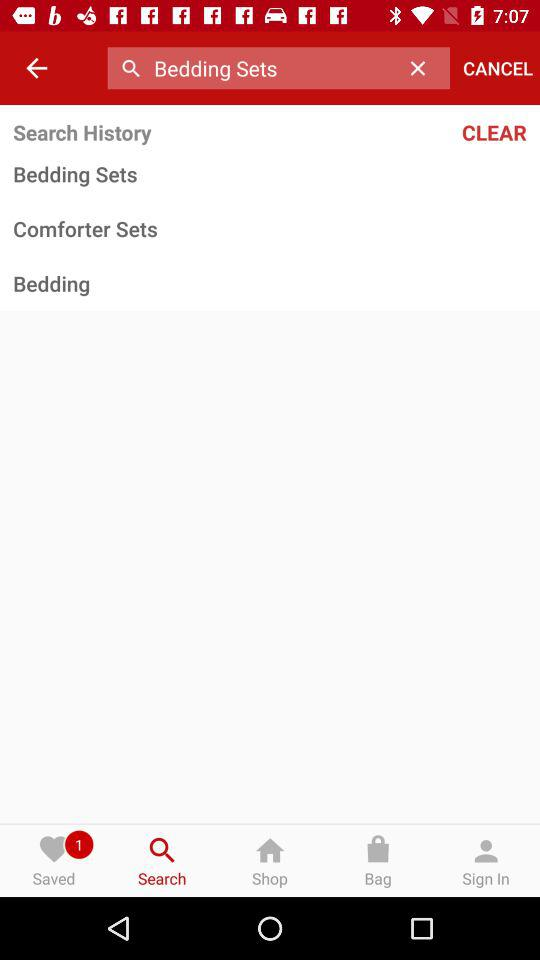How many items are in the search history?
Answer the question using a single word or phrase. 3 